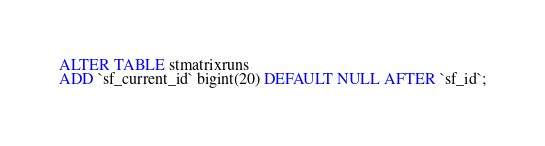<code> <loc_0><loc_0><loc_500><loc_500><_SQL_>ALTER TABLE stmatrixruns
ADD `sf_current_id` bigint(20) DEFAULT NULL AFTER `sf_id`;</code> 